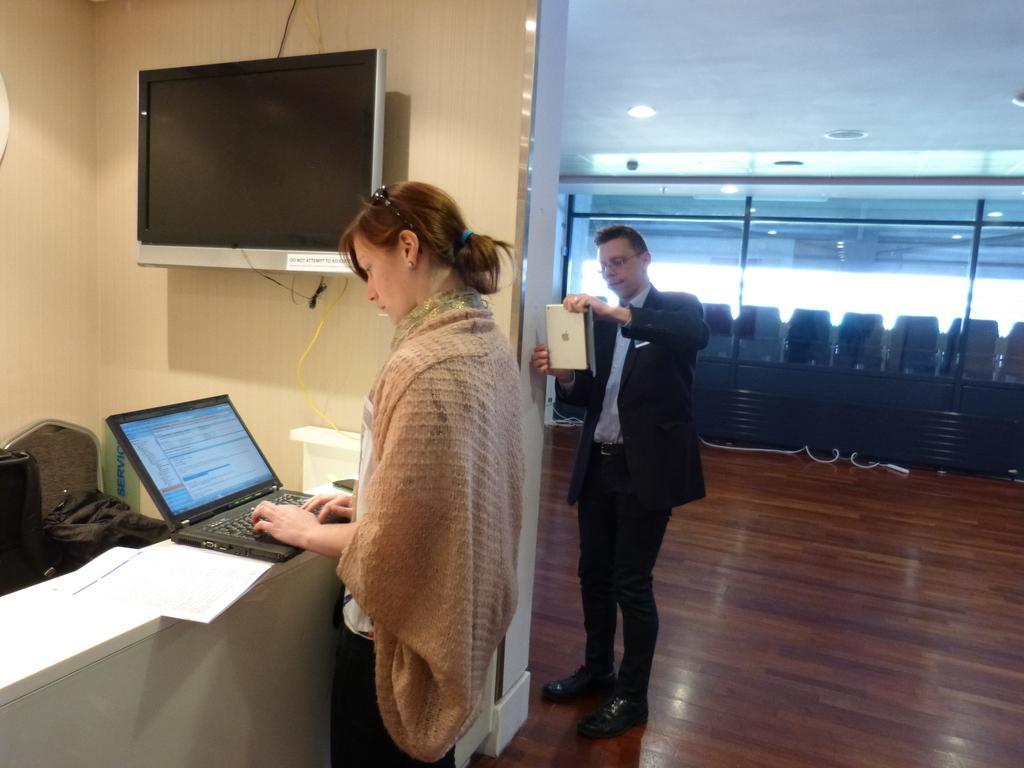Describe this image in one or two sentences. There is a woman with laptop and man with apple macbook beside TV on the wall. 